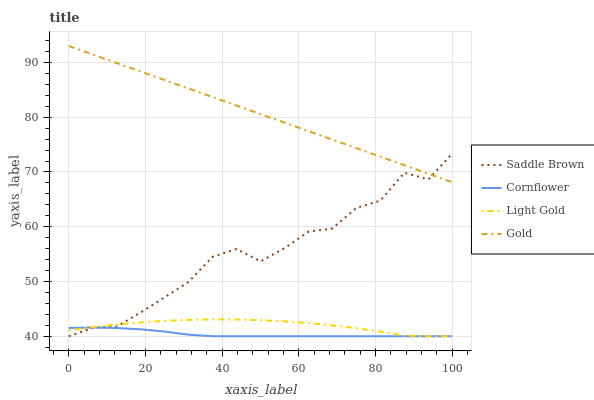Does Cornflower have the minimum area under the curve?
Answer yes or no. Yes. Does Gold have the maximum area under the curve?
Answer yes or no. Yes. Does Light Gold have the minimum area under the curve?
Answer yes or no. No. Does Light Gold have the maximum area under the curve?
Answer yes or no. No. Is Gold the smoothest?
Answer yes or no. Yes. Is Saddle Brown the roughest?
Answer yes or no. Yes. Is Light Gold the smoothest?
Answer yes or no. No. Is Light Gold the roughest?
Answer yes or no. No. Does Cornflower have the lowest value?
Answer yes or no. Yes. Does Gold have the lowest value?
Answer yes or no. No. Does Gold have the highest value?
Answer yes or no. Yes. Does Light Gold have the highest value?
Answer yes or no. No. Is Cornflower less than Gold?
Answer yes or no. Yes. Is Gold greater than Cornflower?
Answer yes or no. Yes. Does Light Gold intersect Cornflower?
Answer yes or no. Yes. Is Light Gold less than Cornflower?
Answer yes or no. No. Is Light Gold greater than Cornflower?
Answer yes or no. No. Does Cornflower intersect Gold?
Answer yes or no. No. 